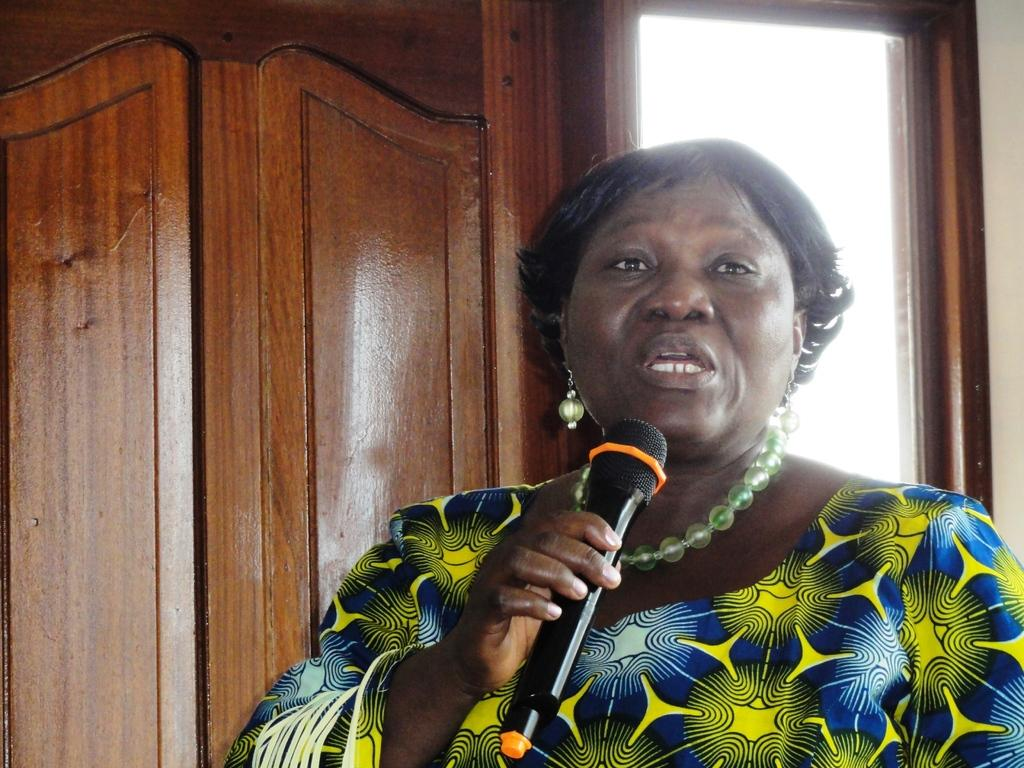Who is present in the image? There are women in the image. What are the women doing in the image? The women are standing and speaking. What object is being used by the women in the image? A microphone is being used by the women. Can you see a kitten playing near the seashore in the image? There is no kitten or seashore present in the image. 